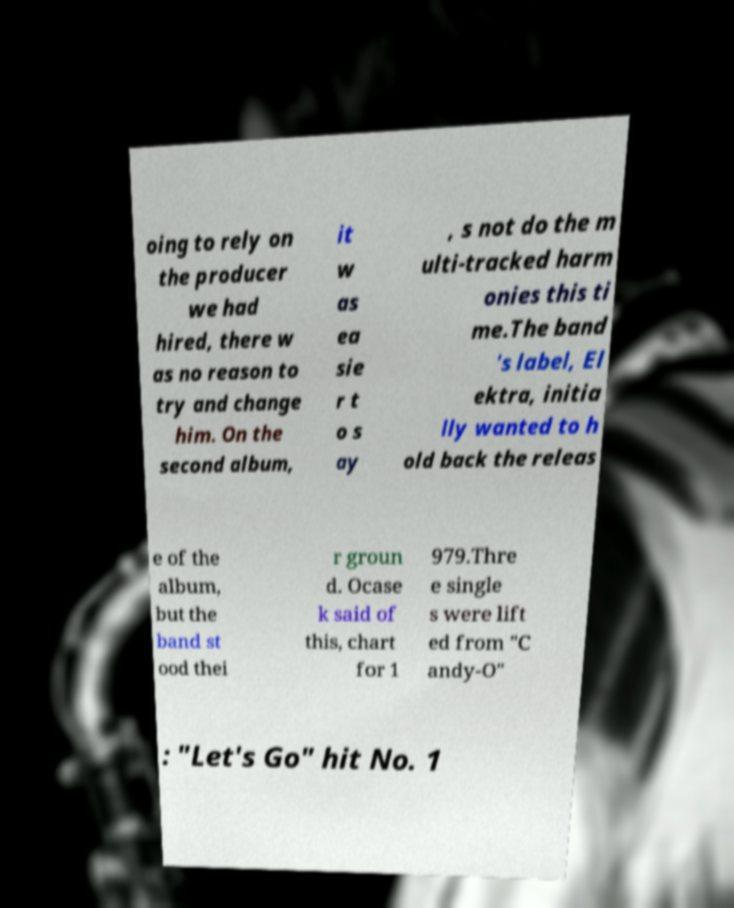For documentation purposes, I need the text within this image transcribed. Could you provide that? oing to rely on the producer we had hired, there w as no reason to try and change him. On the second album, it w as ea sie r t o s ay , s not do the m ulti-tracked harm onies this ti me.The band 's label, El ektra, initia lly wanted to h old back the releas e of the album, but the band st ood thei r groun d. Ocase k said of this, chart for 1 979.Thre e single s were lift ed from "C andy-O" : "Let's Go" hit No. 1 